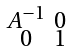<formula> <loc_0><loc_0><loc_500><loc_500>\begin{smallmatrix} A ^ { - 1 } & 0 \\ 0 & 1 \end{smallmatrix}</formula> 